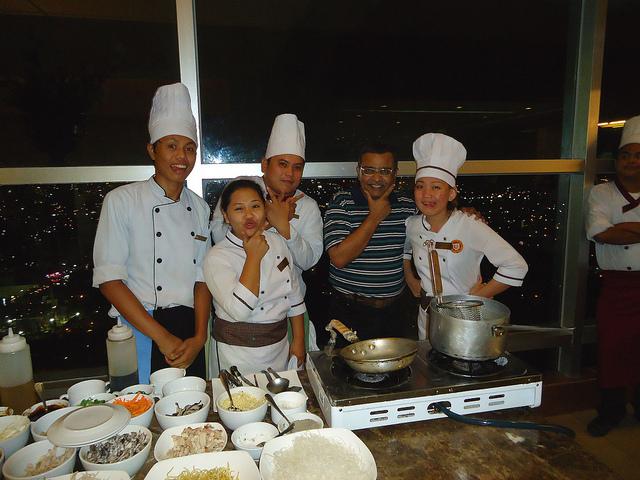Which person is in the black hat?
Short answer required. None. How many people are wearing hats?
Give a very brief answer. 4. What are the people wearing on their heads?
Concise answer only. Chef hats. In what profession are the people in white?
Be succinct. Chefs. 